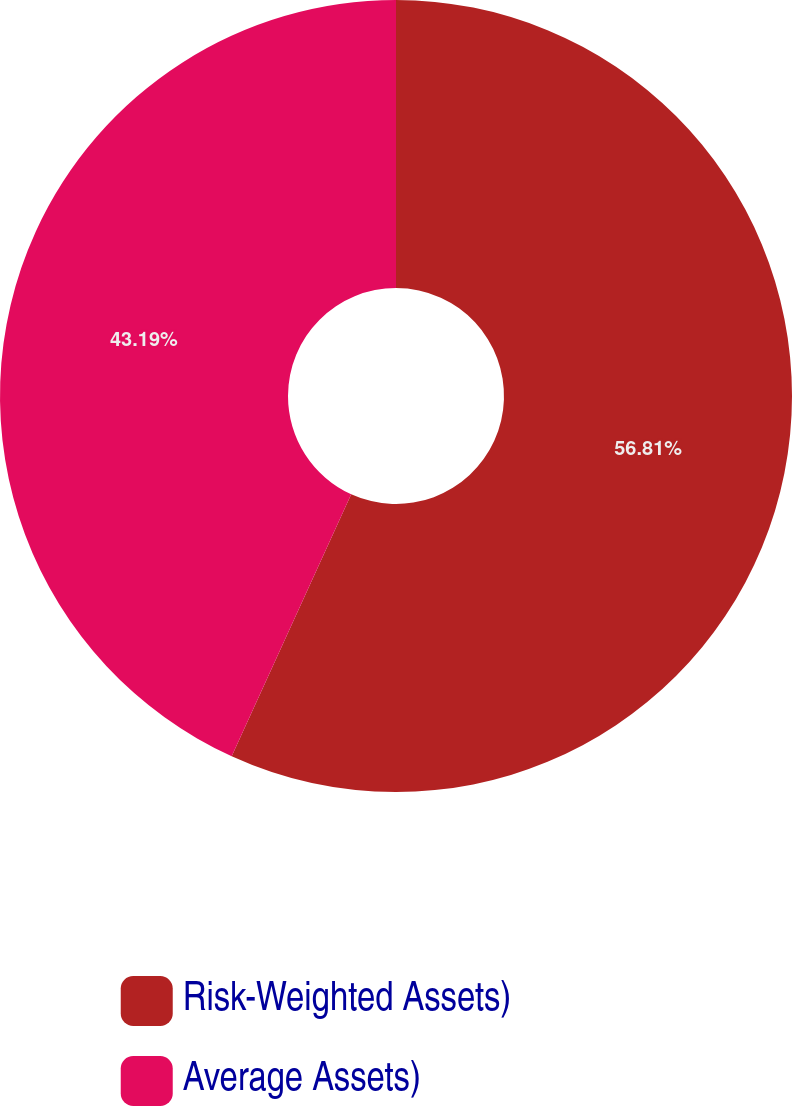Convert chart. <chart><loc_0><loc_0><loc_500><loc_500><pie_chart><fcel>Risk-Weighted Assets)<fcel>Average Assets)<nl><fcel>56.81%<fcel>43.19%<nl></chart> 